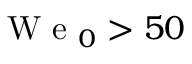<formula> <loc_0><loc_0><loc_500><loc_500>W e _ { 0 } > 5 0</formula> 